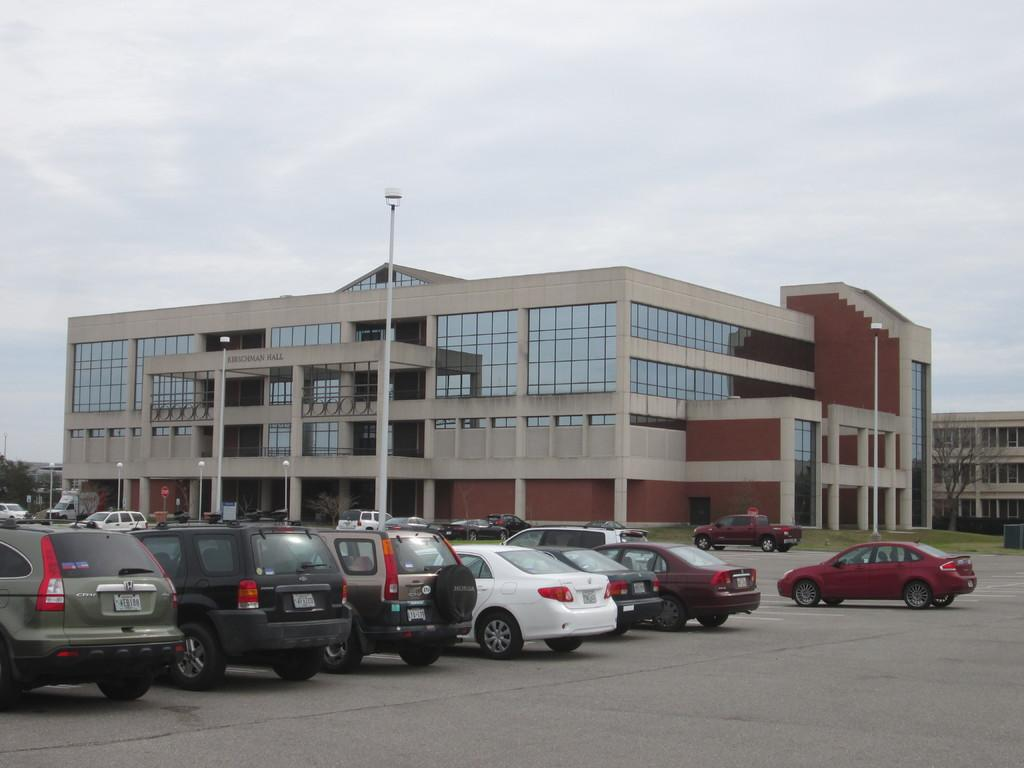What can be seen on the path in the image? There are vehicles on the path in the image. What else is present on the path? There are lights on the path in the image. What can be seen in the background of the image? There are trees and buildings visible in the background of the image. How would you describe the sky in the image? The sky is cloudy in the image. What type of work is being done by the carriage in the image? There is no carriage present in the image. What is your opinion on the lighting on the path in the image? The conversation does not involve expressing opinions, as we are focusing on describing the image based on the provided facts. 